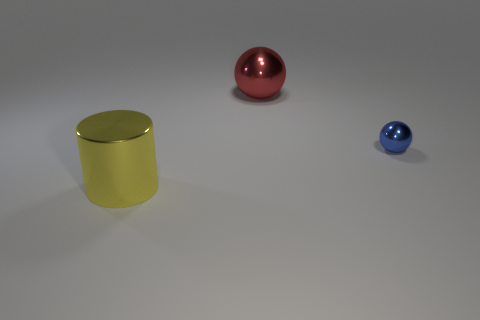The big thing that is the same material as the big red ball is what shape?
Offer a terse response. Cylinder. Does the yellow cylinder have the same material as the large object that is behind the tiny shiny object?
Your answer should be compact. Yes. There is a big metal thing to the right of the large cylinder; is there a blue shiny thing that is on the left side of it?
Give a very brief answer. No. There is a red object that is the same shape as the tiny blue metal object; what material is it?
Give a very brief answer. Metal. How many large objects are in front of the ball that is in front of the big metal ball?
Your answer should be compact. 1. Is there any other thing that has the same color as the cylinder?
Your answer should be compact. No. How many things are either red metal objects or large things behind the yellow metallic thing?
Your response must be concise. 1. The large thing to the right of the metal object left of the large metallic object that is on the right side of the large yellow shiny cylinder is made of what material?
Give a very brief answer. Metal. What size is the blue sphere that is made of the same material as the large yellow cylinder?
Offer a very short reply. Small. What is the color of the ball in front of the big object that is on the right side of the yellow metallic object?
Offer a very short reply. Blue. 